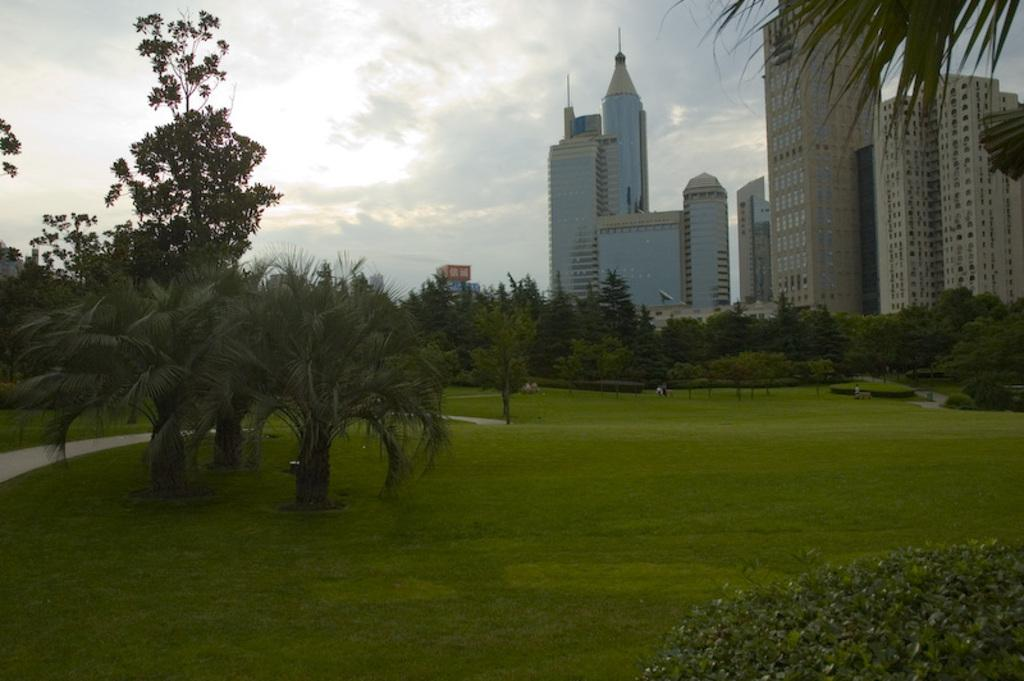What type of ground is visible in the image? There is a greenery ground in the image. What can be seen in the background of the image? There are trees, people, and buildings in the background of the image. How would you describe the sky in the image? The sky is visible in the image and is a bit cloudy. How many dimes can be seen on the ground in the image? There are no dimes present in the image; it features a greenery ground. What type of amusement can be seen in the image? There is no amusement present in the image; it features a greenery ground, trees, people, buildings, and a cloudy sky. 